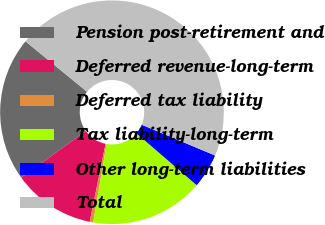Convert chart. <chart><loc_0><loc_0><loc_500><loc_500><pie_chart><fcel>Pension post-retirement and<fcel>Deferred revenue-long-term<fcel>Deferred tax liability<fcel>Tax liability-long-term<fcel>Other long-term liabilities<fcel>Total<nl><fcel>20.86%<fcel>11.88%<fcel>0.5%<fcel>16.37%<fcel>4.99%<fcel>45.4%<nl></chart> 